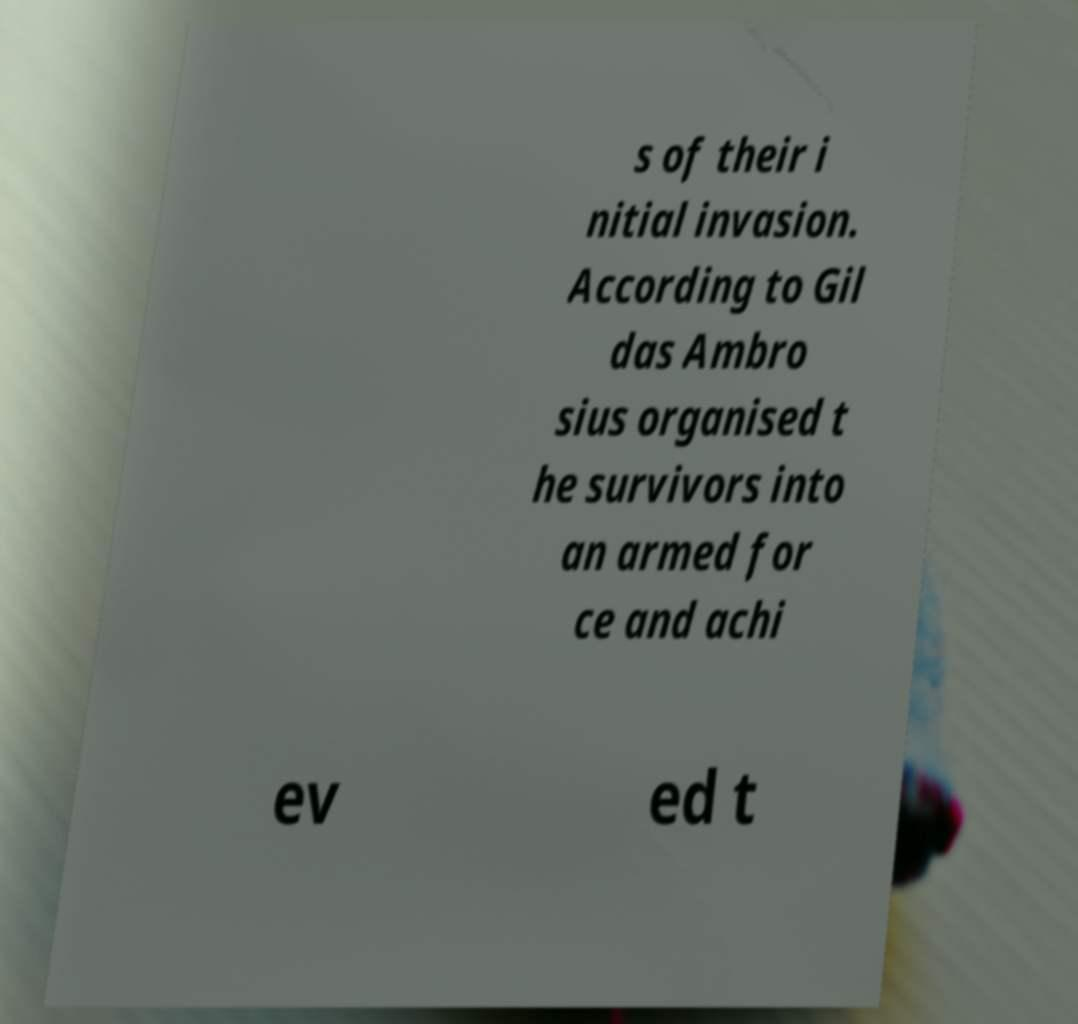For documentation purposes, I need the text within this image transcribed. Could you provide that? s of their i nitial invasion. According to Gil das Ambro sius organised t he survivors into an armed for ce and achi ev ed t 